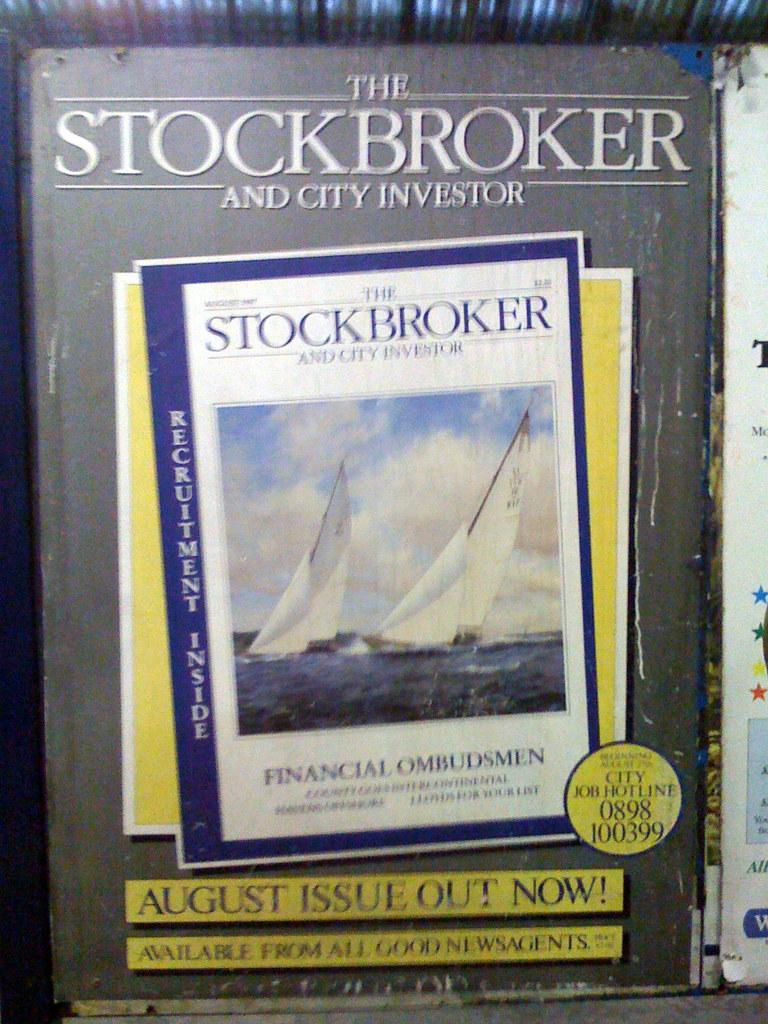<image>
Provide a brief description of the given image. A copy of The Stockbroker and City Investor sits next to another book. 